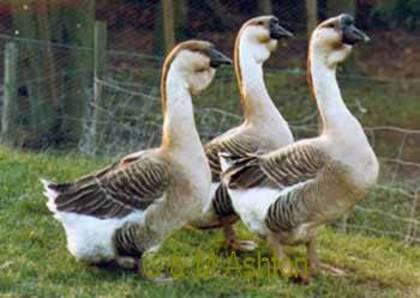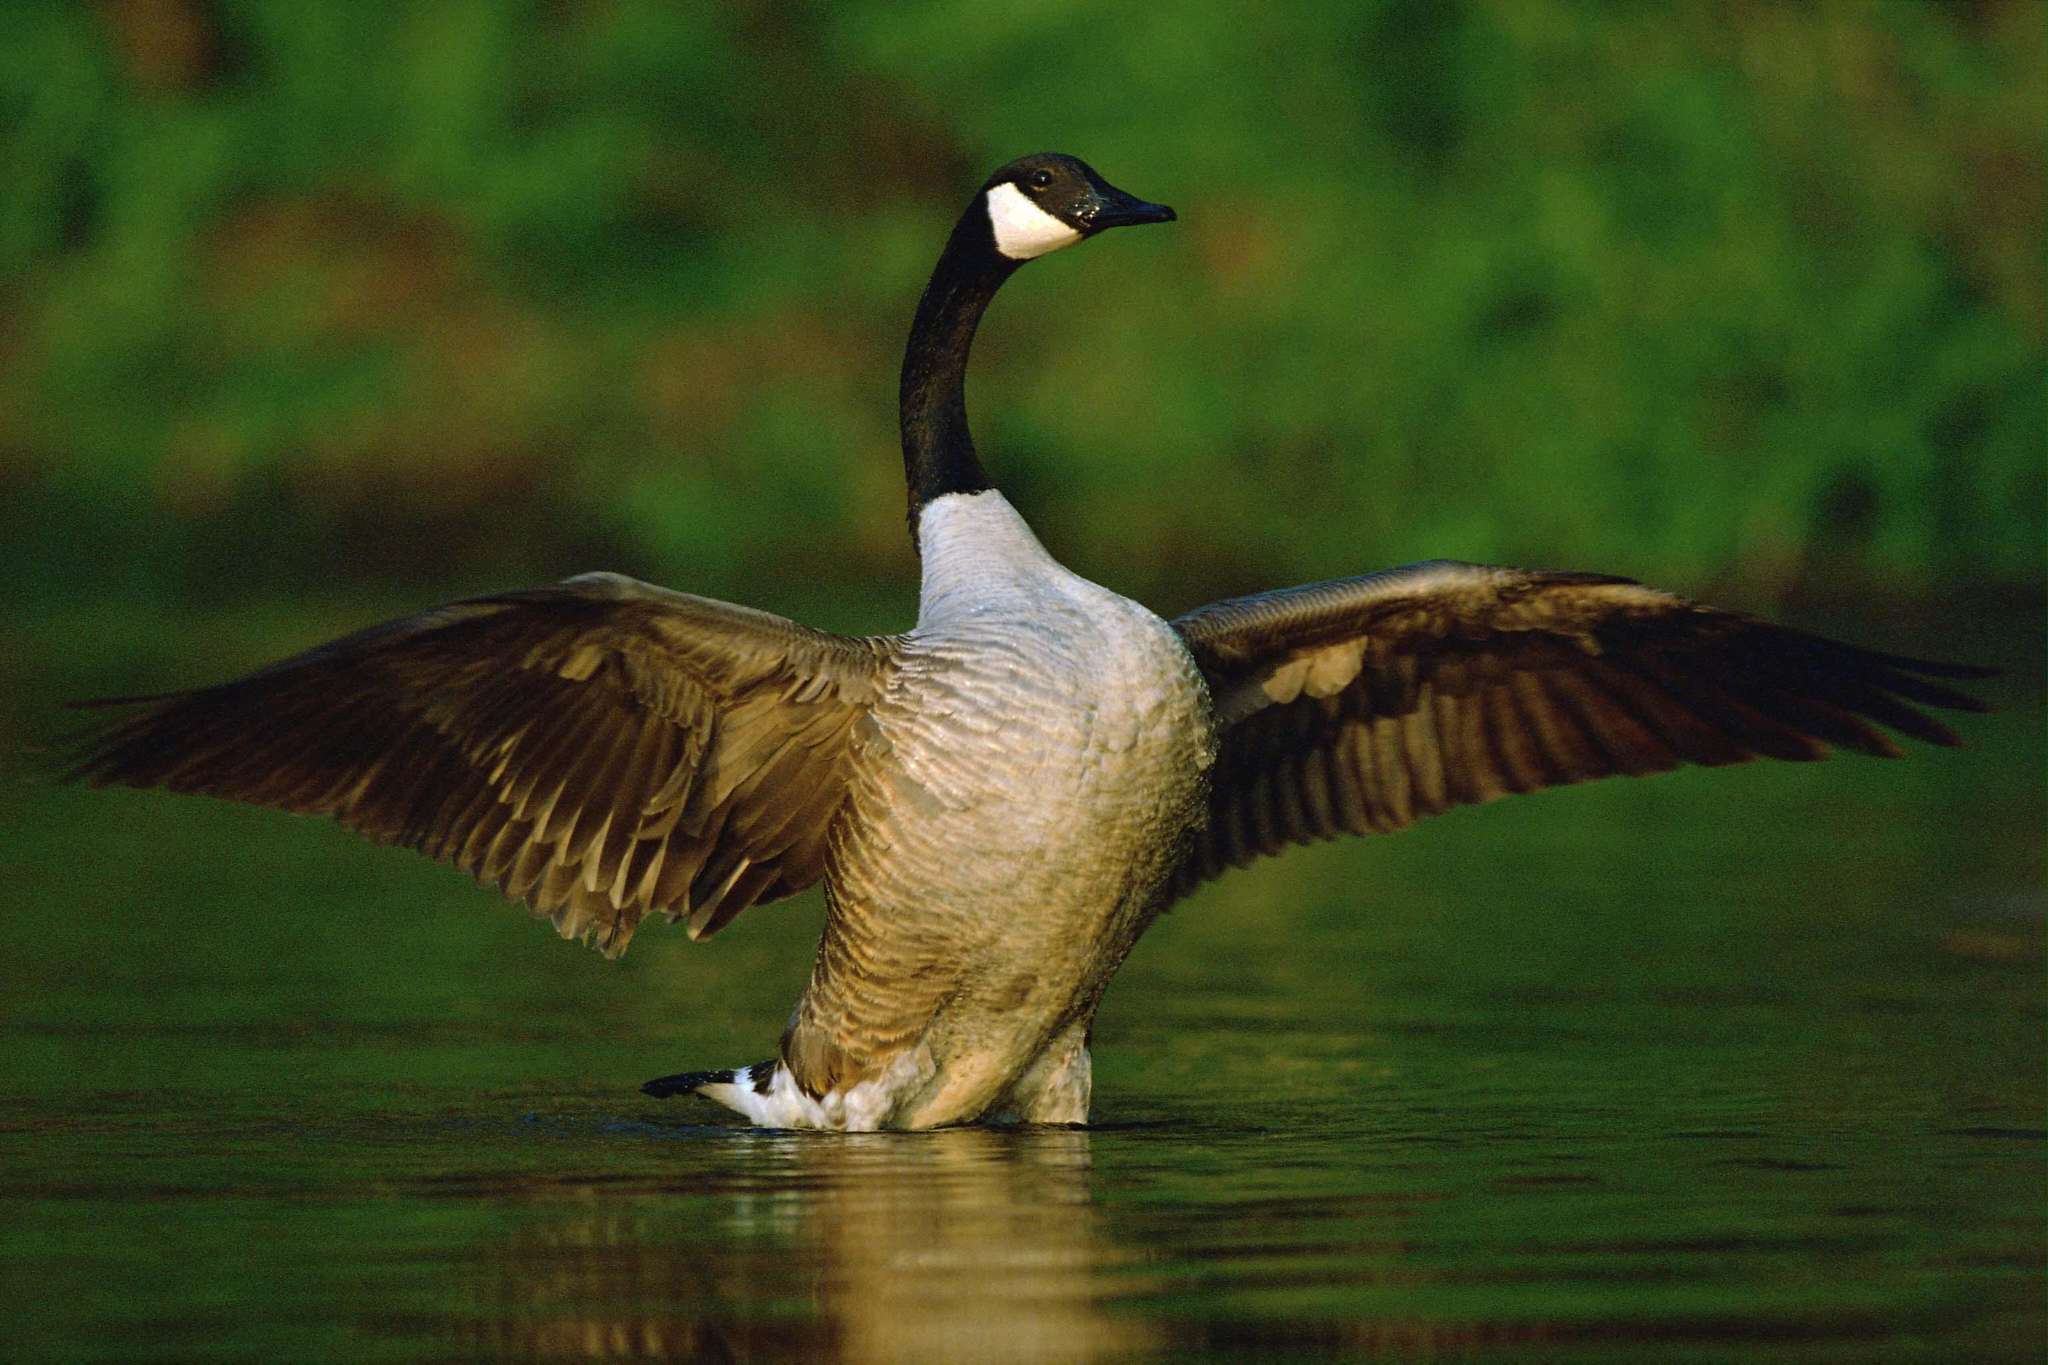The first image is the image on the left, the second image is the image on the right. Examine the images to the left and right. Is the description "The left image shows fowl standing on grass." accurate? Answer yes or no. Yes. 